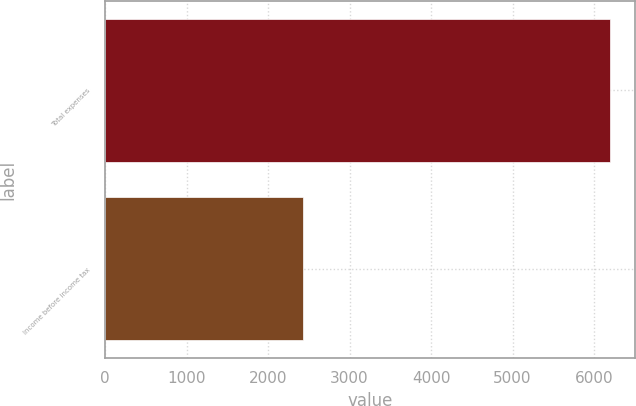<chart> <loc_0><loc_0><loc_500><loc_500><bar_chart><fcel>Total expenses<fcel>Income before income tax<nl><fcel>6190<fcel>2427<nl></chart> 